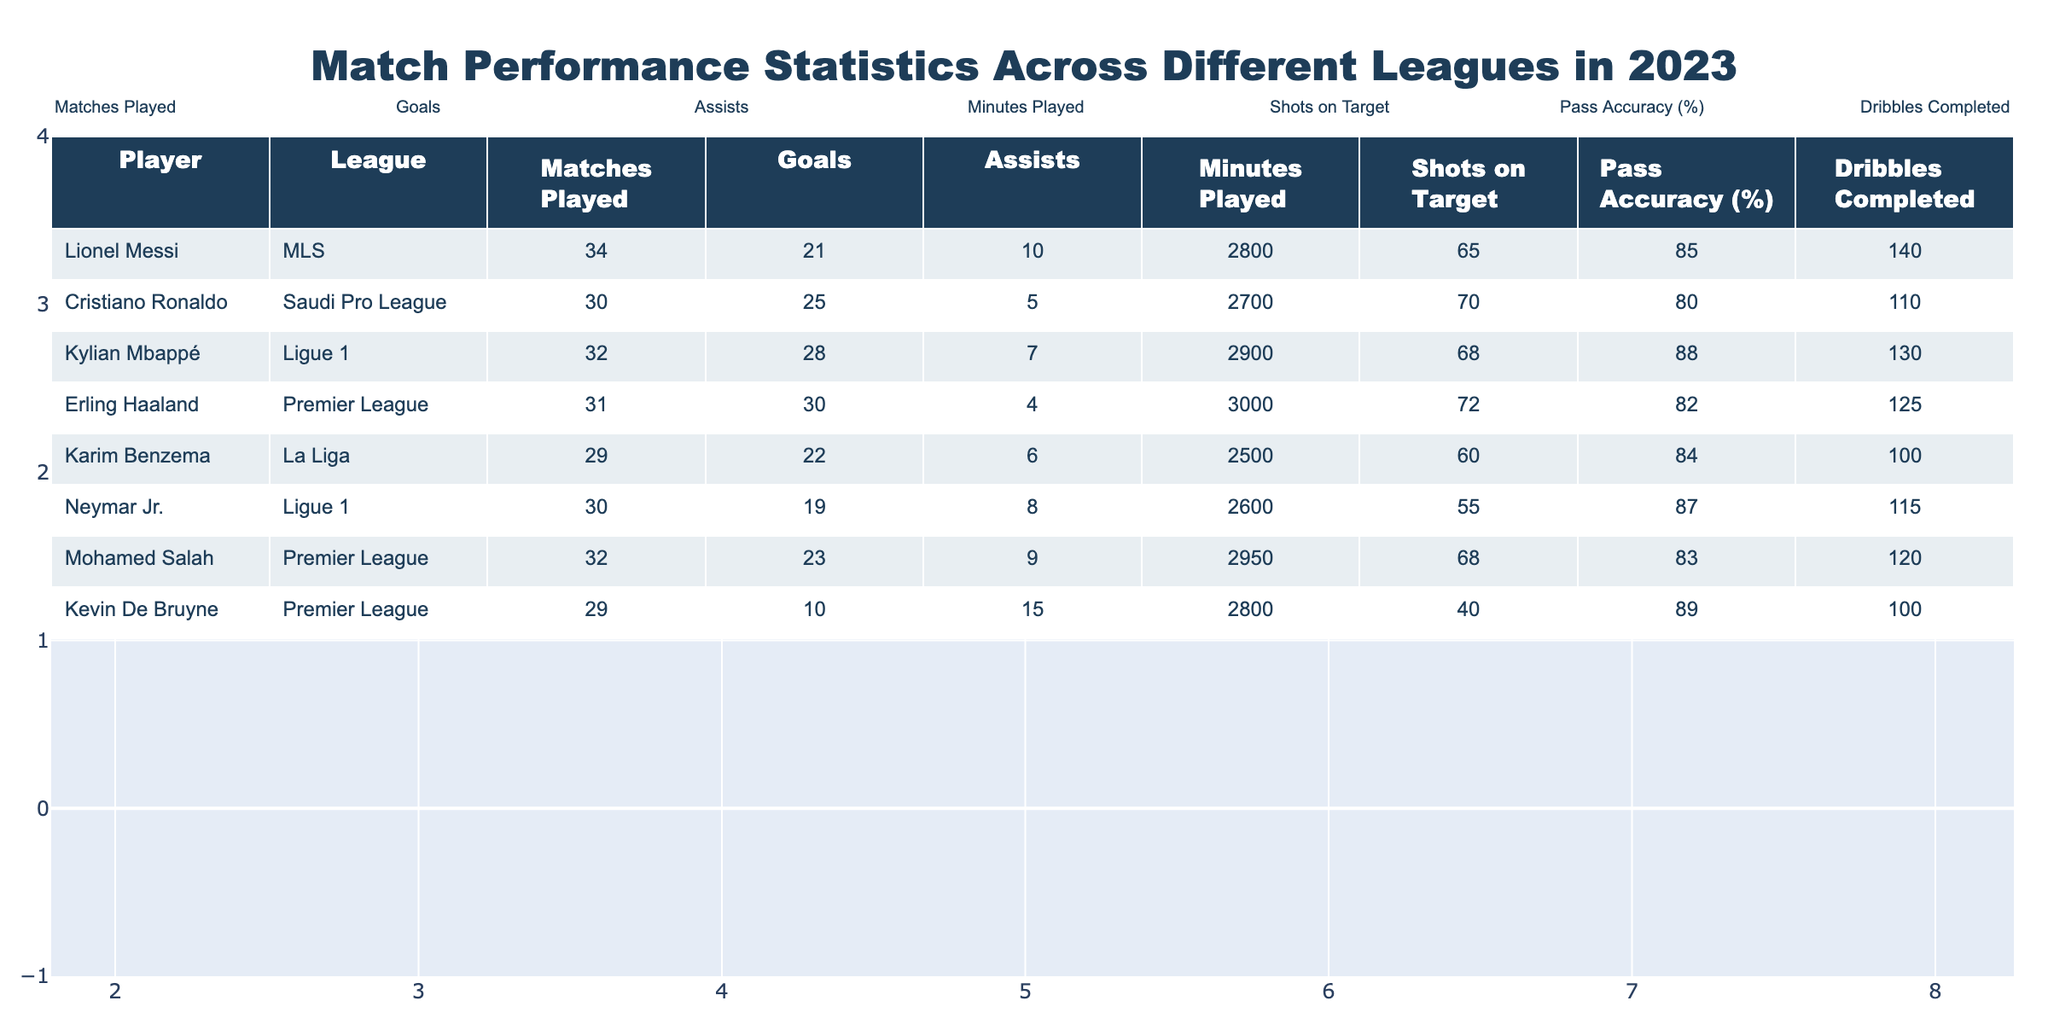What is the total number of goals scored by Kylian Mbappé in 2023? Kylian Mbappé appears in the table with 28 goals scored. Therefore, the total number of goals he scored is simply the number listed next to him.
Answer: 28 Which player had the highest number of assists in the Premier League? The Premier League section includes Kevin De Bruyne (15 assists), Mohamed Salah (9 assists), and Erling Haaland (4 assists). Comparing these figures, Kevin De Bruyne has the highest number of assists.
Answer: Kevin De Bruyne What is the average number of goals scored by players in Ligue 1? The players listed in Ligue 1 are Kylian Mbappé (28 goals) and Neymar Jr. (19 goals). To find the average, add the goals together (28 + 19 = 47) and then divide by the number of players (2). Thus, the average is 47 / 2 = 23.5.
Answer: 23.5 Did Mohamed Salah score more goals than Karim Benzema in 2023? Mohamed Salah scored 23 goals while Karim Benzema scored 22 goals. Since 23 is greater than 22, Mohamed Salah scored more goals.
Answer: Yes What league had the player with the highest shot accuracy? The data shows that Lionel Messi has shot accuracy of 85%, Cristiano Ronaldo has 80%, Kylian Mbappé has 88%, Erling Haaland has 82%, Karim Benzema has 84%, Neymar Jr. has 87%, and both Kevin De Bruyne and Mohamed Salah have lowered shot accuracies compared to leading players. Kylian Mbappé's 88% makes him the standout in this category, identifying Ligue 1 as the league with the highest shot accuracy player.
Answer: Ligue 1 Which player had the fewest minutes played among those in the table? Comparing the minutes played: Messi (2800), Ronaldo (2700), Mbappé (2900), Haaland (3000), Benzema (2500), Neymar (2600), Salah (2950), and De Bruyne (2800). Karim Benzema has the lowest minutes played at 2500.
Answer: Karim Benzema Calculate the total assists for all players in the MLS and the Saudi Pro League combined. In the MLS, Lionel Messi contributed 10 assists and in Saudi Pro League Cristiano Ronaldo had 5 assists. Adding them together gives (10 + 5 = 15) assists overall for both leagues.
Answer: 15 What is the difference in shots on target between Erling Haaland and Neymar Jr.? Erling Haaland had 72 shots on target while Neymar Jr. had 55. To find the difference, subtract Neymar's shots from Haaland's: (72 - 55 = 17).
Answer: 17 Which player had the highest number of matches played? Analyzing the matches played, Messi has 34, Ronaldo has 30, Mbappé has 32, Haaland has 31, Benzema has 29, Neymar has 30, Salah has 32, and De Bruyne has 29. Thus, Lionel Messi has played the most matches at 34.
Answer: Lionel Messi 